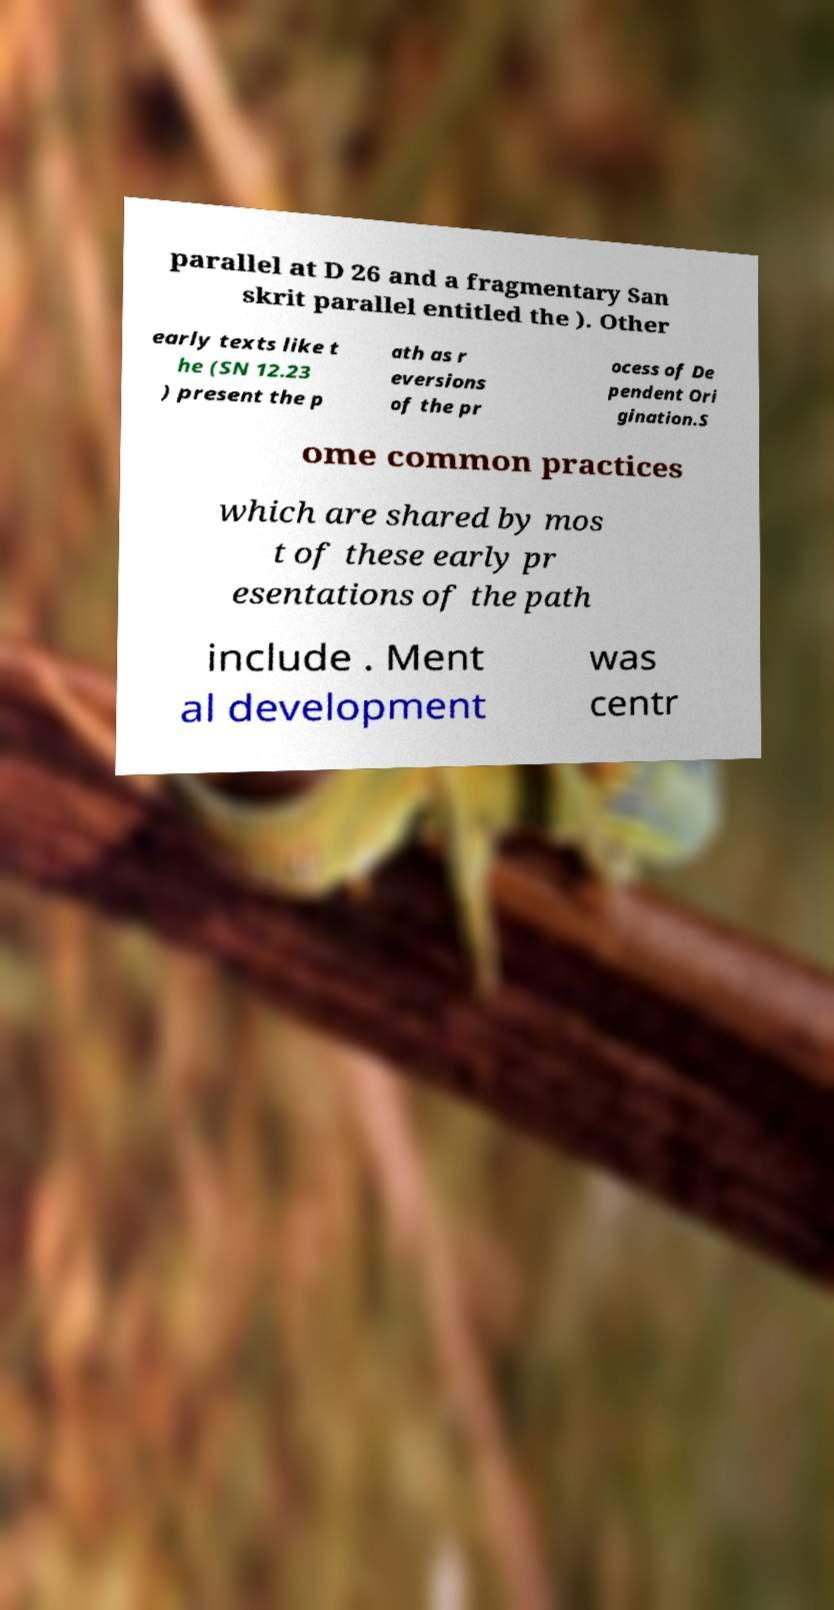For documentation purposes, I need the text within this image transcribed. Could you provide that? parallel at D 26 and a fragmentary San skrit parallel entitled the ). Other early texts like t he (SN 12.23 ) present the p ath as r eversions of the pr ocess of De pendent Ori gination.S ome common practices which are shared by mos t of these early pr esentations of the path include . Ment al development was centr 